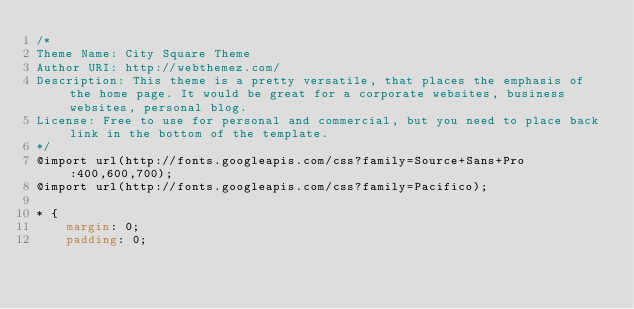<code> <loc_0><loc_0><loc_500><loc_500><_CSS_>/*
Theme Name: City Square Theme
Author URI: http://webthemez.com/
Description: This theme is a pretty versatile, that places the emphasis of the home page. It would be great for a corporate websites, business websites, personal blog.
License: Free to use for personal and commercial, but you need to place back link in the bottom of the template.
*/
@import url(http://fonts.googleapis.com/css?family=Source+Sans+Pro:400,600,700);
@import url(http://fonts.googleapis.com/css?family=Pacifico);

* {
    margin: 0;
    padding: 0;</code> 